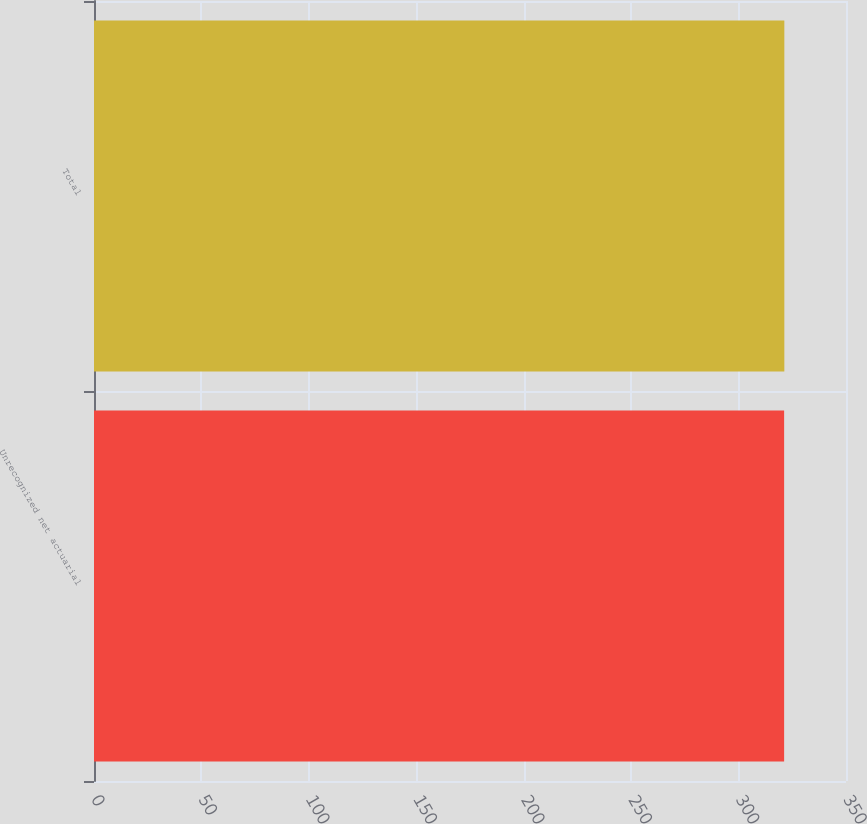Convert chart to OTSL. <chart><loc_0><loc_0><loc_500><loc_500><bar_chart><fcel>Unrecognized net actuarial<fcel>Total<nl><fcel>321.2<fcel>321.3<nl></chart> 